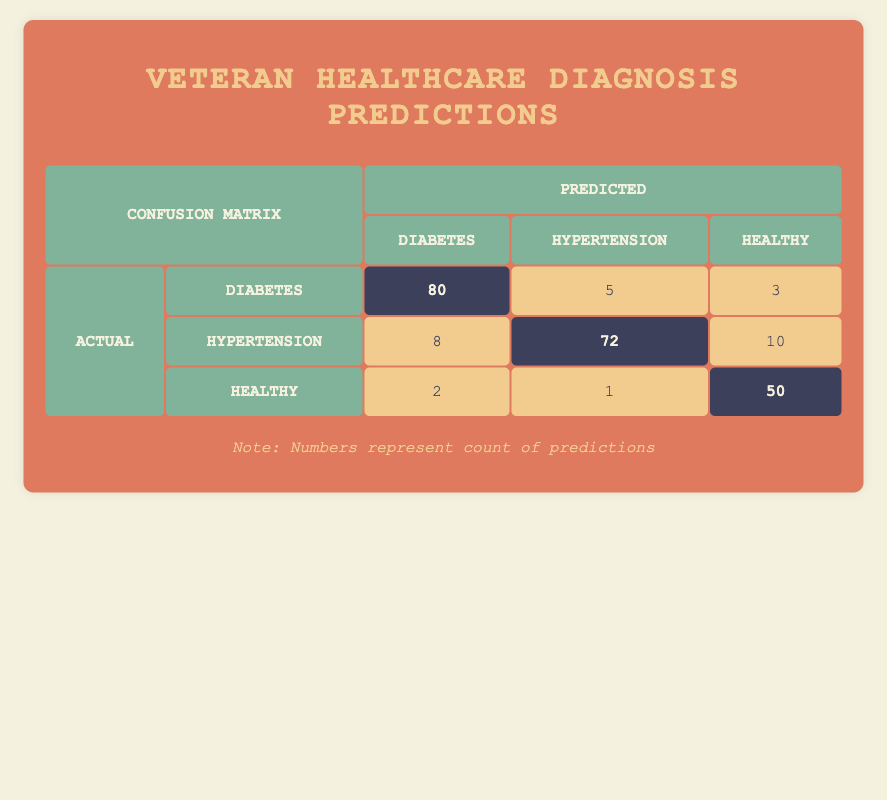What is the number of veterans predicted to have diabetes? According to the table, the count for veterans predicted to have diabetes (with actual diabetes) is 80. This is clear from the highlighted cell in the row for actual diabetes, under the diabetes column of predicted.
Answer: 80 How many veterans were falsely predicted to have hypertension when they actually had diabetes? The entry in the confusion matrix shows that 5 veterans with actual diabetes were falsely predicted to have hypertension. This is found in the row for actual diabetes and under the hypertension column of predicted.
Answer: 5 What is the total count of healthy veterans predicted correctly? The table shows that 50 veterans were correctly predicted as healthy. This is found in the highlighted cell for the row indicating actual healthy, under the healthy column of predicted.
Answer: 50 Is it true that more veterans were predicted to be healthy when they actually had hypertension than those who were falsely predicted to have diabetes? The table shows that 10 veterans with actual hypertension were predicted as healthy, while 8 veterans with actual hypertension were incorrectly predicted to have diabetes. Since 10 is greater than 8, the statement is true.
Answer: Yes What is the average number of predictions for each health condition? We can find the total predictions by adding up all counts: 80 + 5 + 3 + 72 + 8 + 10 + 50 + 2 + 1 = 231. There are 9 predictions, so the average is 231 divided by 9, which equals approximately 25.67.
Answer: 25.67 